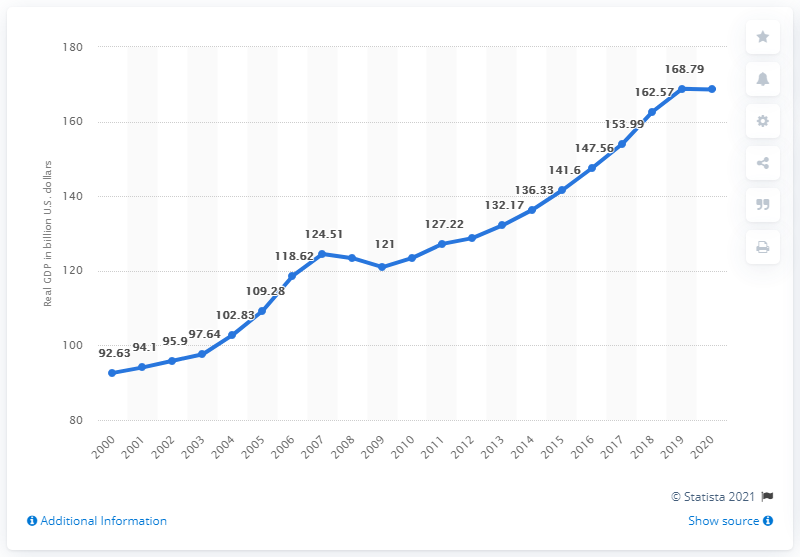Outline some significant characteristics in this image. In the previous year, Utah's Gross Domestic Product (GDP) was valued at 168.62 dollars. In 2020, Utah's Gross Domestic Product (GDP) was 168.62 billion dollars. 